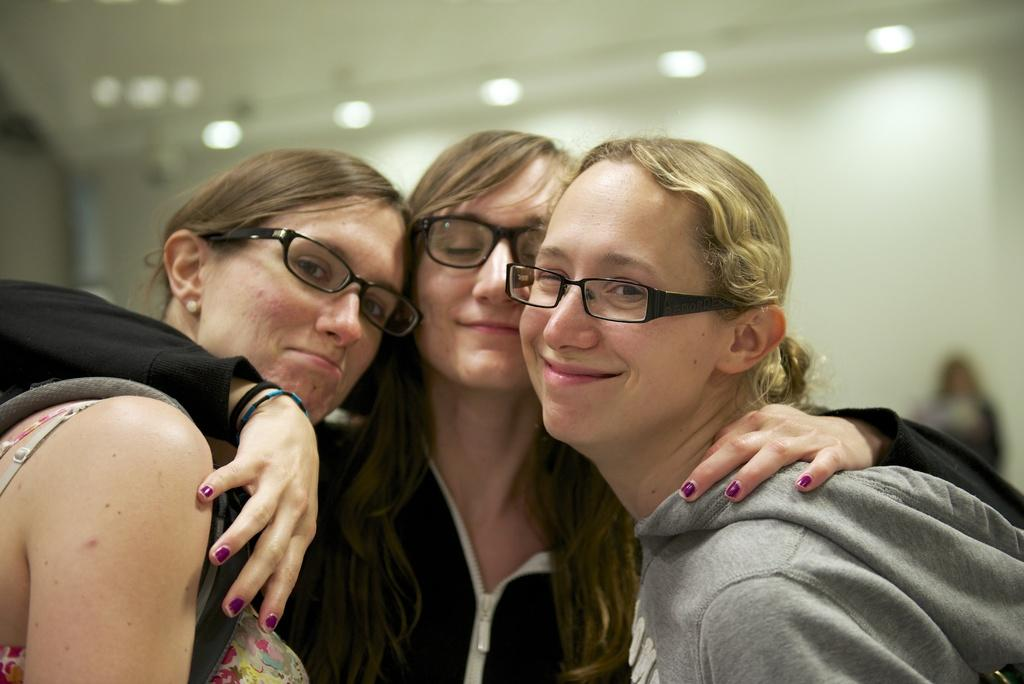Who or what can be seen in the image? There are people in the image. What feature is present on the roof in the image? There are lights attached to the roof in the image. What type of list can be seen on the people's clothing in the image? There is no list visible on the people's clothing in the image. Are there any bushes or plants present in the image? The provided facts do not mention any bushes or plants in the image. 